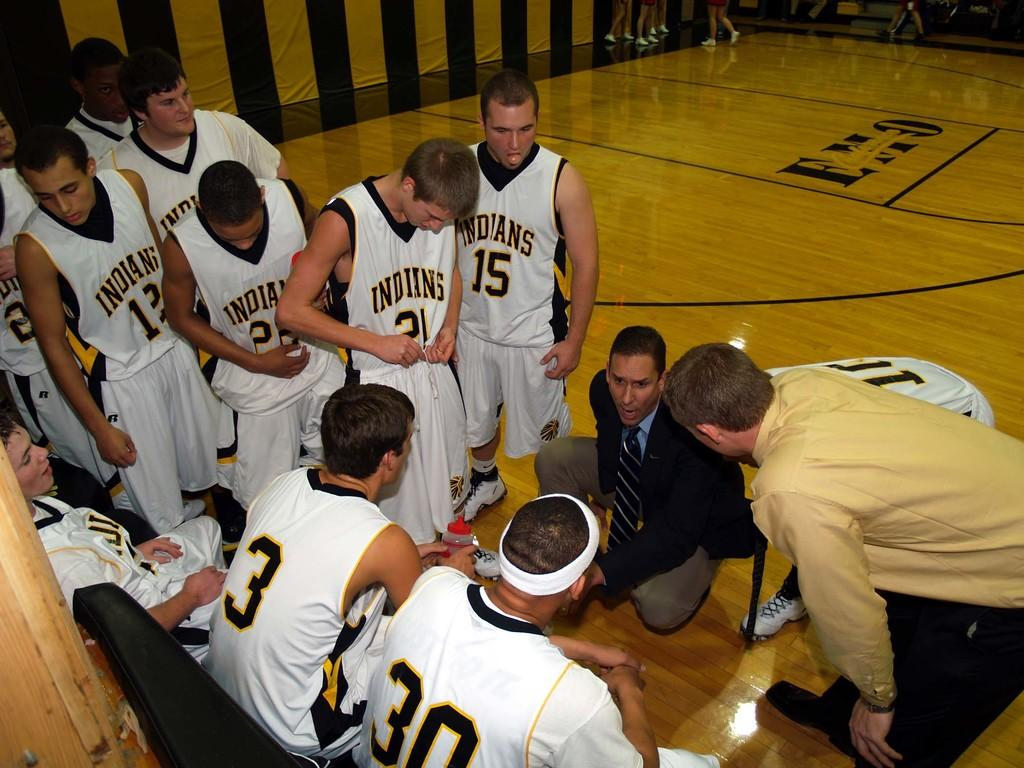<image>
Write a terse but informative summary of the picture. A basketball team huddling around their coach, with the name Indians on the uniform. 